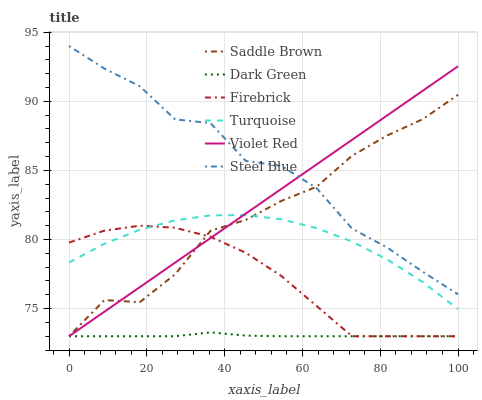Does Dark Green have the minimum area under the curve?
Answer yes or no. Yes. Does Steel Blue have the maximum area under the curve?
Answer yes or no. Yes. Does Firebrick have the minimum area under the curve?
Answer yes or no. No. Does Firebrick have the maximum area under the curve?
Answer yes or no. No. Is Violet Red the smoothest?
Answer yes or no. Yes. Is Steel Blue the roughest?
Answer yes or no. Yes. Is Firebrick the smoothest?
Answer yes or no. No. Is Firebrick the roughest?
Answer yes or no. No. Does Violet Red have the lowest value?
Answer yes or no. Yes. Does Turquoise have the lowest value?
Answer yes or no. No. Does Steel Blue have the highest value?
Answer yes or no. Yes. Does Firebrick have the highest value?
Answer yes or no. No. Is Turquoise less than Steel Blue?
Answer yes or no. Yes. Is Steel Blue greater than Turquoise?
Answer yes or no. Yes. Does Firebrick intersect Turquoise?
Answer yes or no. Yes. Is Firebrick less than Turquoise?
Answer yes or no. No. Is Firebrick greater than Turquoise?
Answer yes or no. No. Does Turquoise intersect Steel Blue?
Answer yes or no. No. 